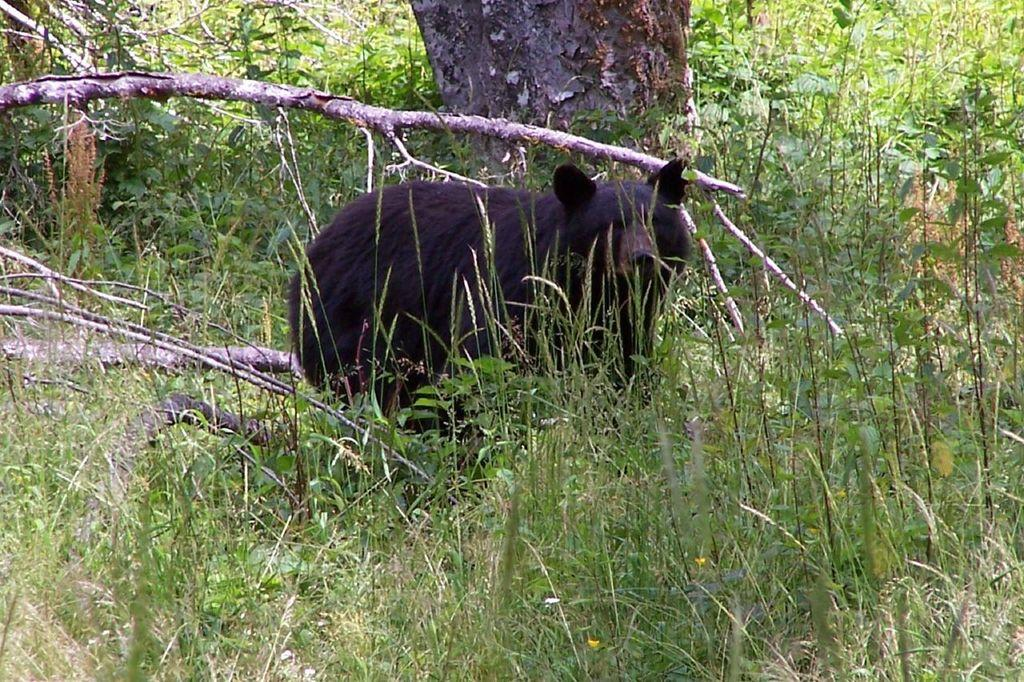What animal is in the picture? There is a bear in the picture. What is the bear's position in the image? The bear is standing in the grass. What type of vegetation can be seen in the background? Small plants and trees are visible in the background. What type of zebra can be seen downtown in the image? There is no zebra present in the image, and the location mentioned, "downtown," is not relevant to the image. 